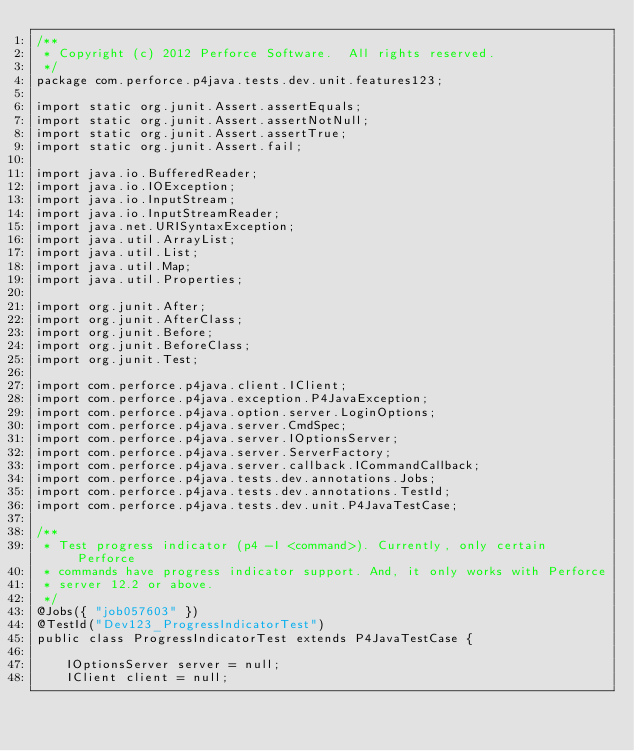<code> <loc_0><loc_0><loc_500><loc_500><_Java_>/**
 * Copyright (c) 2012 Perforce Software.  All rights reserved.
 */
package com.perforce.p4java.tests.dev.unit.features123;

import static org.junit.Assert.assertEquals;
import static org.junit.Assert.assertNotNull;
import static org.junit.Assert.assertTrue;
import static org.junit.Assert.fail;

import java.io.BufferedReader;
import java.io.IOException;
import java.io.InputStream;
import java.io.InputStreamReader;
import java.net.URISyntaxException;
import java.util.ArrayList;
import java.util.List;
import java.util.Map;
import java.util.Properties;

import org.junit.After;
import org.junit.AfterClass;
import org.junit.Before;
import org.junit.BeforeClass;
import org.junit.Test;

import com.perforce.p4java.client.IClient;
import com.perforce.p4java.exception.P4JavaException;
import com.perforce.p4java.option.server.LoginOptions;
import com.perforce.p4java.server.CmdSpec;
import com.perforce.p4java.server.IOptionsServer;
import com.perforce.p4java.server.ServerFactory;
import com.perforce.p4java.server.callback.ICommandCallback;
import com.perforce.p4java.tests.dev.annotations.Jobs;
import com.perforce.p4java.tests.dev.annotations.TestId;
import com.perforce.p4java.tests.dev.unit.P4JavaTestCase;

/**
 * Test progress indicator (p4 -I <command>). Currently, only certain Perforce
 * commands have progress indicator support. And, it only works with Perforce
 * server 12.2 or above.
 */
@Jobs({ "job057603" })
@TestId("Dev123_ProgressIndicatorTest")
public class ProgressIndicatorTest extends P4JavaTestCase {

	IOptionsServer server = null;
	IClient client = null;</code> 